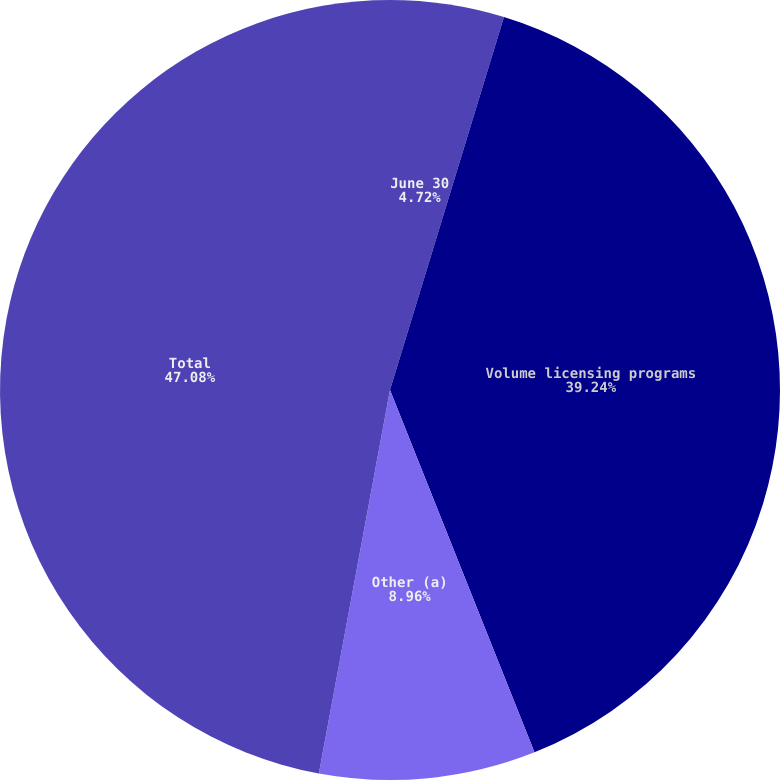Convert chart. <chart><loc_0><loc_0><loc_500><loc_500><pie_chart><fcel>June 30<fcel>Volume licensing programs<fcel>Other (a)<fcel>Total<nl><fcel>4.72%<fcel>39.24%<fcel>8.96%<fcel>47.08%<nl></chart> 